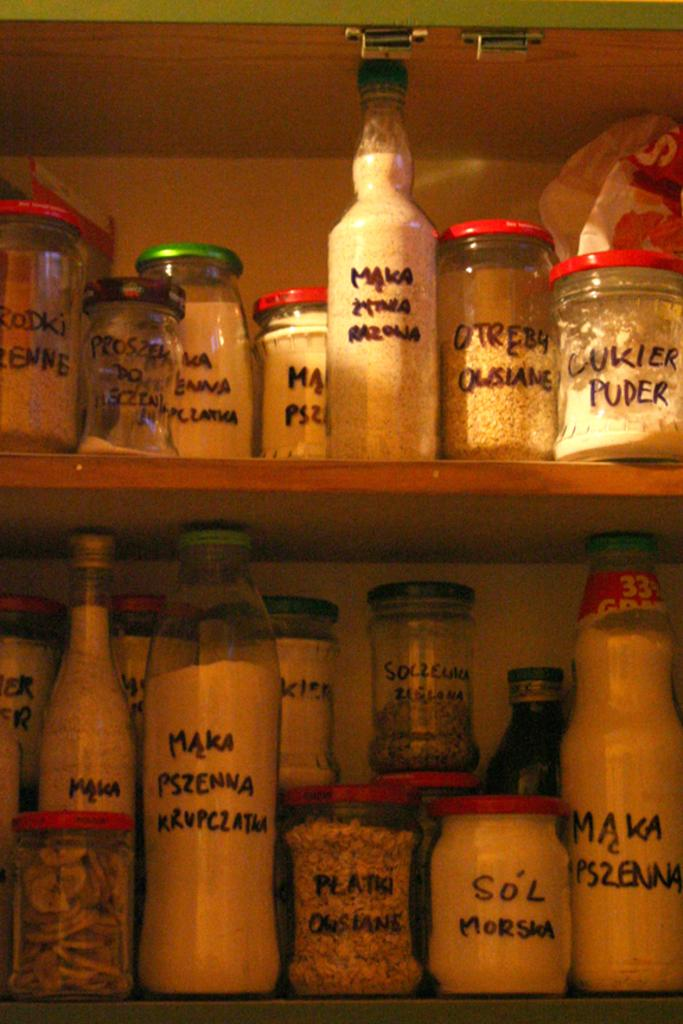What types of containers are present in the image? There are jar and bottle containers in the image. What is inside the containers? There are different types of spices in the containers. How are the containers arranged in the image? The spices are in a rack. What type of division can be seen between the spices in the image? There is no division between the spices in the image; they are all in the same rack. 